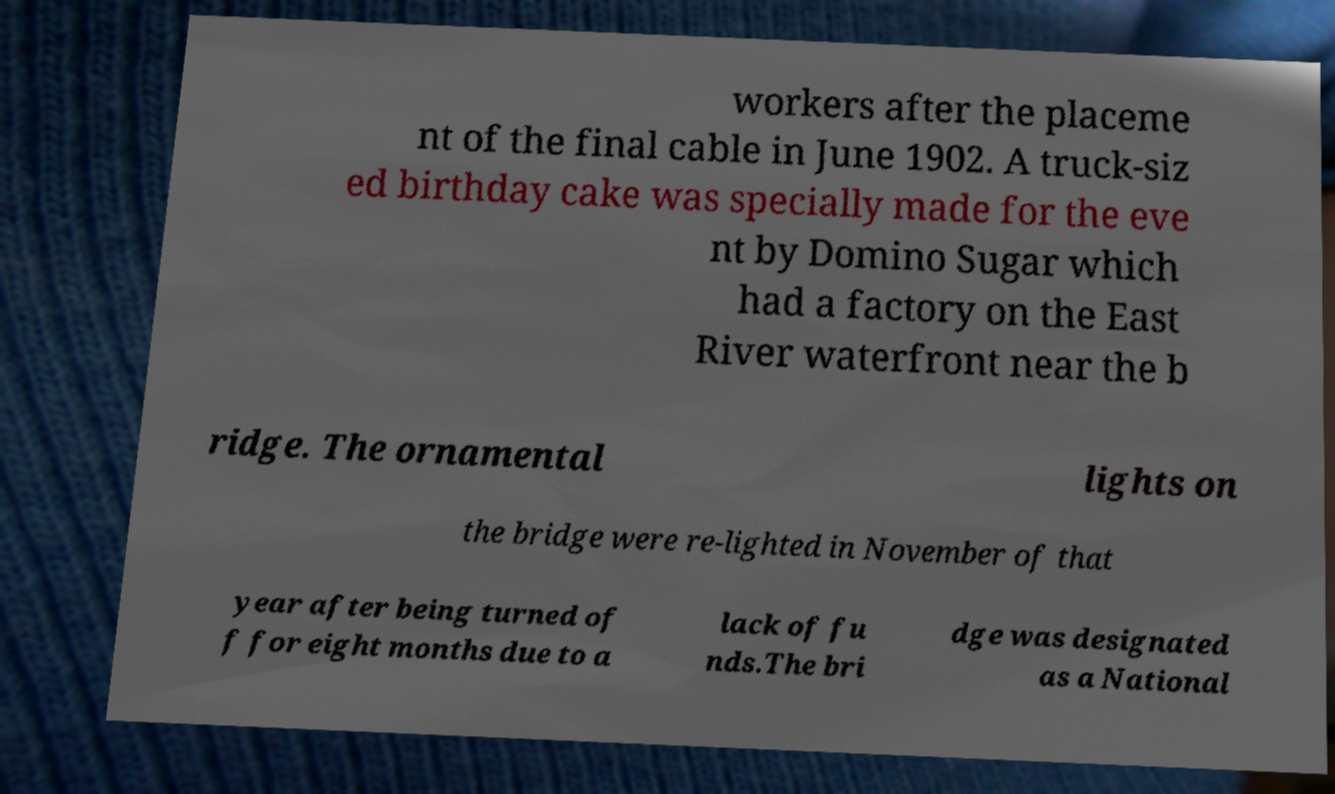Could you extract and type out the text from this image? workers after the placeme nt of the final cable in June 1902. A truck-siz ed birthday cake was specially made for the eve nt by Domino Sugar which had a factory on the East River waterfront near the b ridge. The ornamental lights on the bridge were re-lighted in November of that year after being turned of f for eight months due to a lack of fu nds.The bri dge was designated as a National 